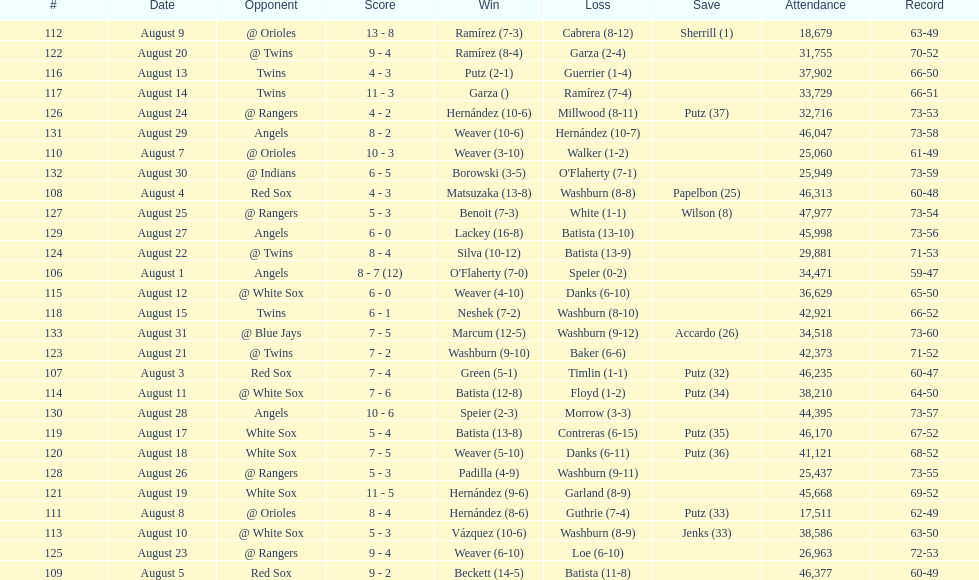How many losses during stretch? 7. 